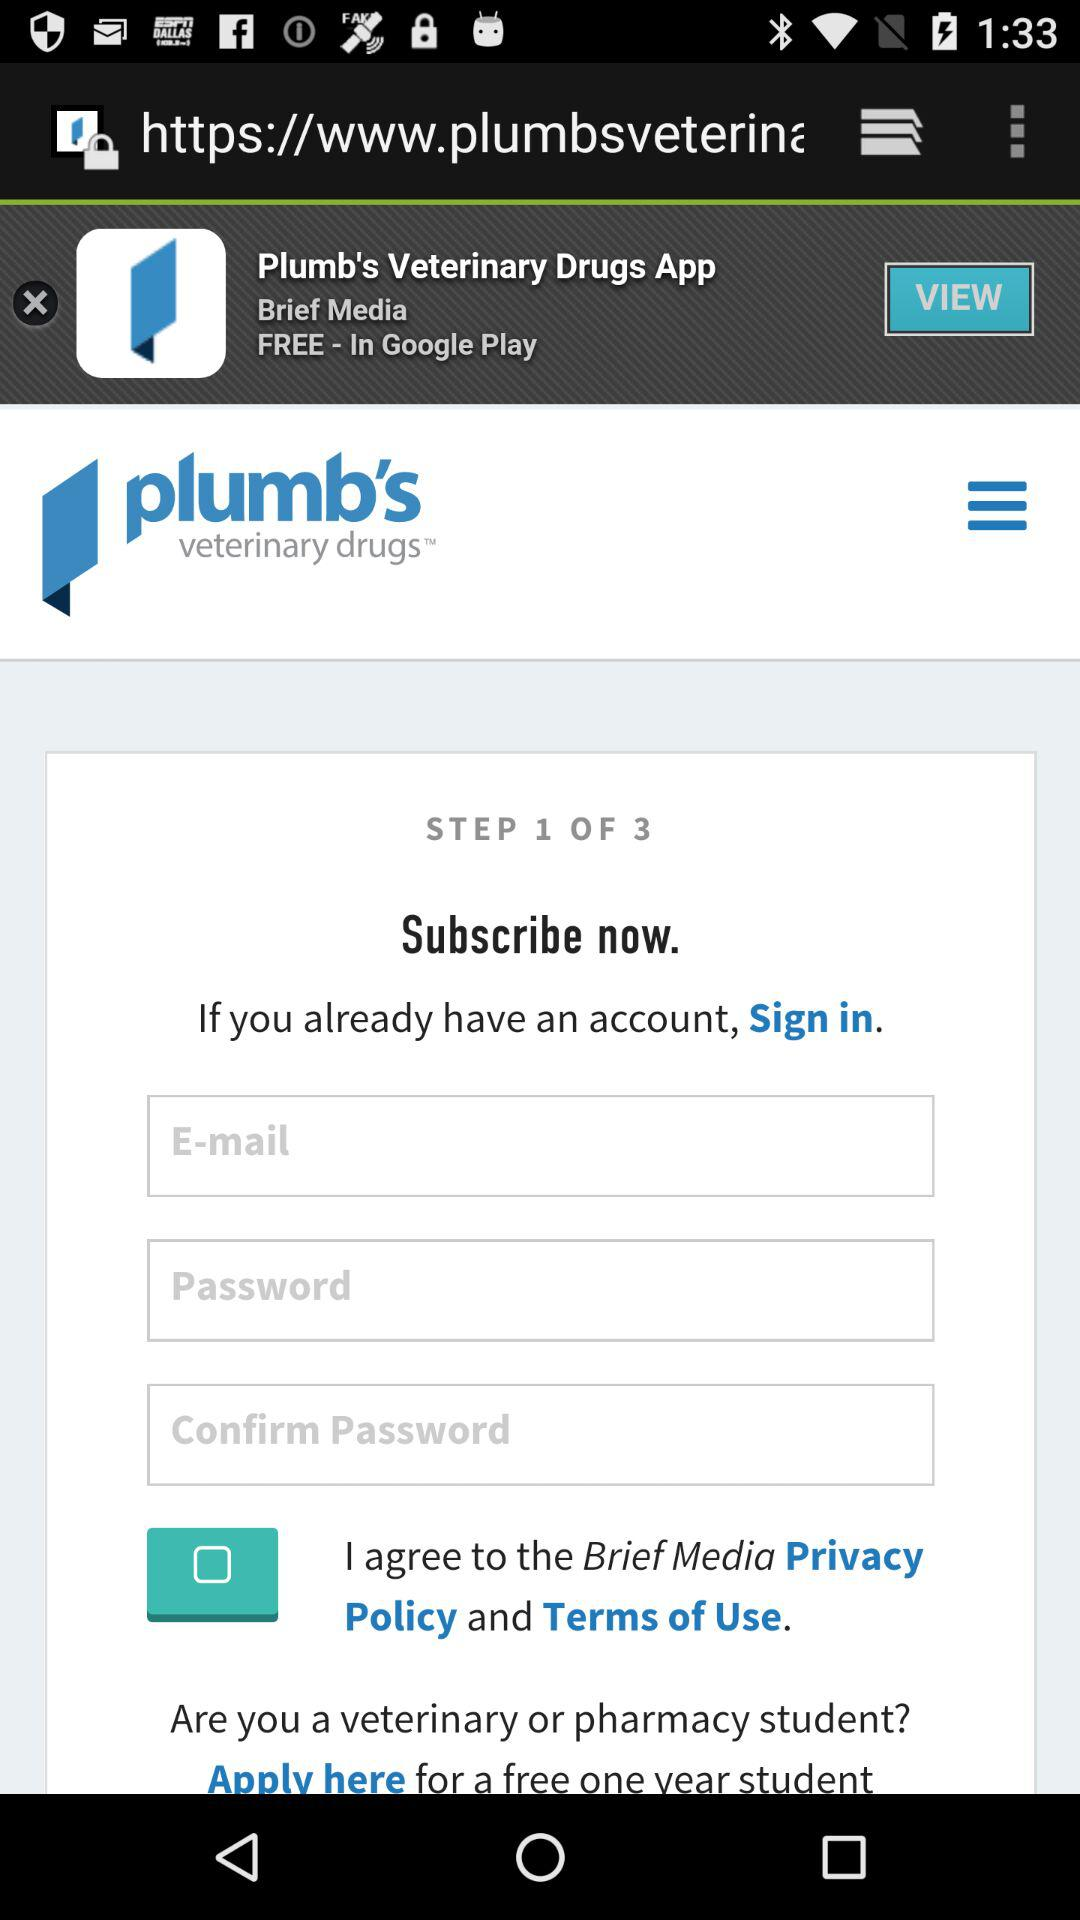How many steps are there in the sign up process?
Answer the question using a single word or phrase. 3 